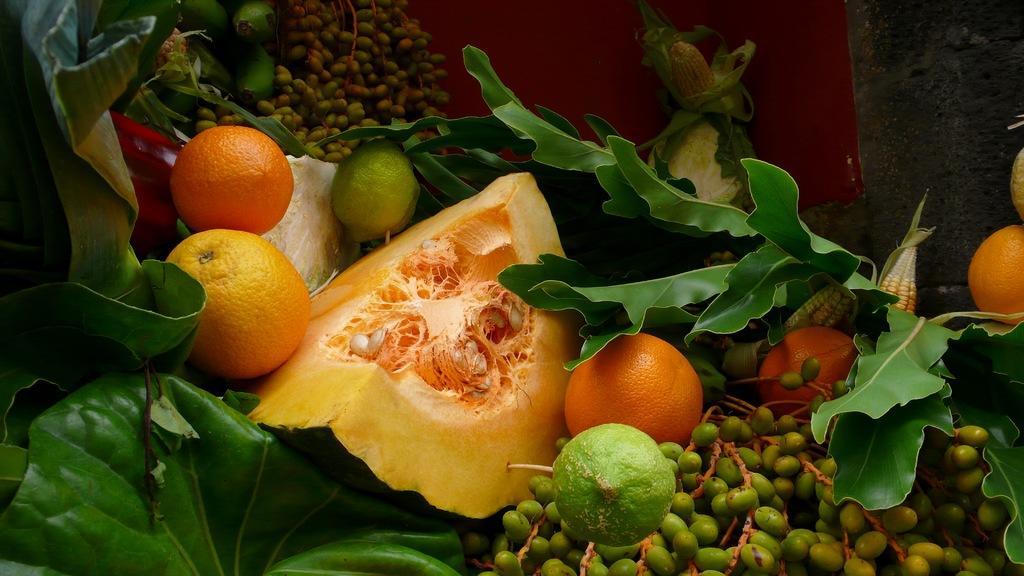What type of fruits can be seen in the image? There are oranges, lemons, and other fruits in the image. What other items are present in the image besides fruits? There is a pumpkin, corn, and leaves in the image. What type of support can be seen being provided to the students in the image? There is no reference to students or support in the image; it features fruits, a pumpkin, corn, and leaves. 